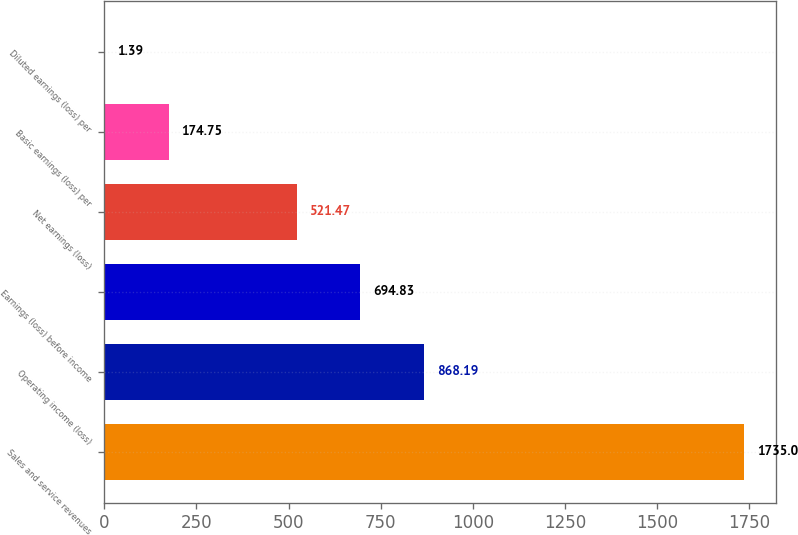Convert chart to OTSL. <chart><loc_0><loc_0><loc_500><loc_500><bar_chart><fcel>Sales and service revenues<fcel>Operating income (loss)<fcel>Earnings (loss) before income<fcel>Net earnings (loss)<fcel>Basic earnings (loss) per<fcel>Diluted earnings (loss) per<nl><fcel>1735<fcel>868.19<fcel>694.83<fcel>521.47<fcel>174.75<fcel>1.39<nl></chart> 